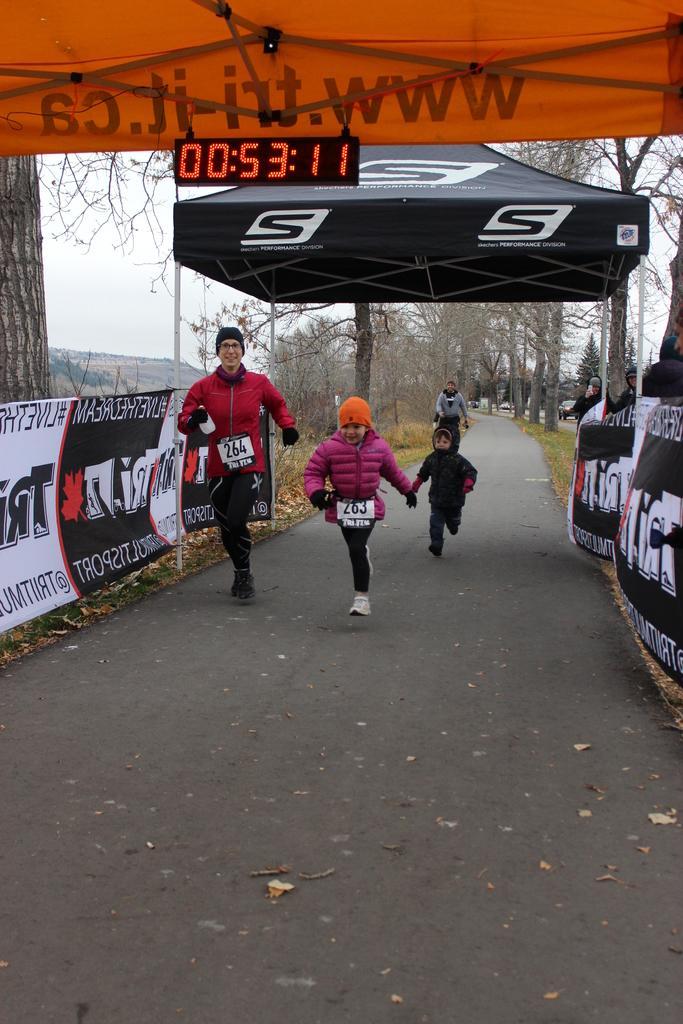Describe this image in one or two sentences. In the center of the image there are persons running on the road. On the right side of the image we can see trees, persons and banners. On the left side of the image we can see banners, trees and hill. In the background there are trees, persons and sky. 